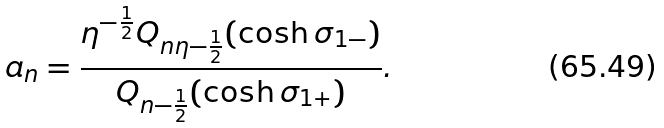Convert formula to latex. <formula><loc_0><loc_0><loc_500><loc_500>a _ { n } = \frac { \eta ^ { - \frac { 1 } { 2 } } Q _ { n \eta - \frac { 1 } { 2 } } ( \cosh \sigma _ { 1 - } ) } { Q _ { n - \frac { 1 } { 2 } } ( \cosh \sigma _ { 1 + } ) } .</formula> 